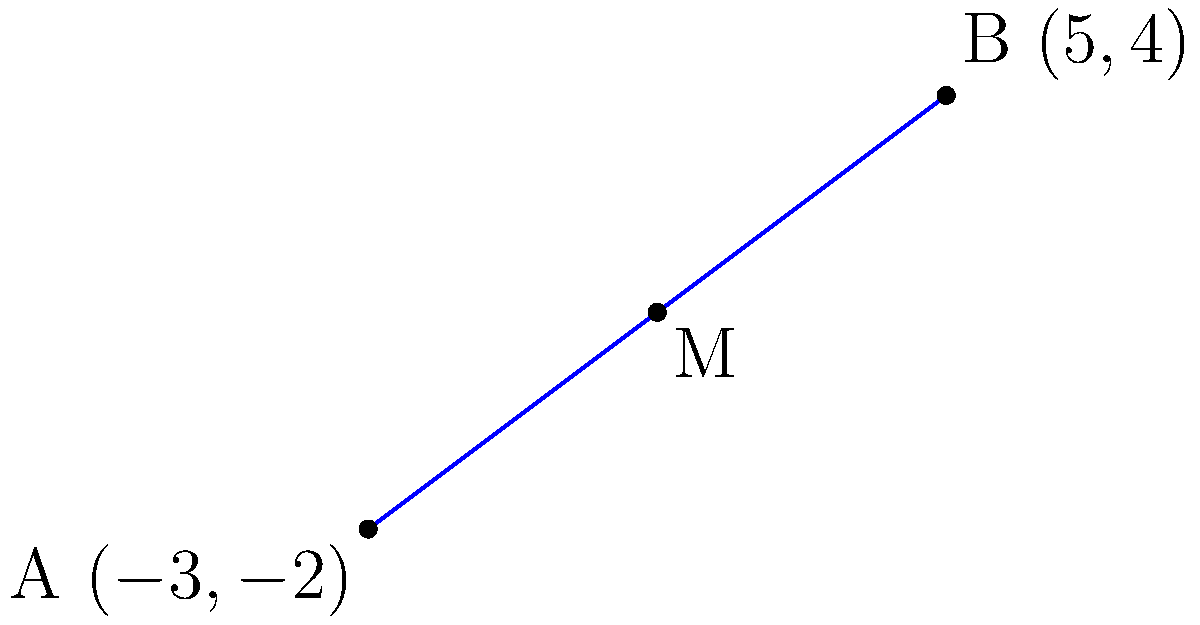A technology company operates two data centers located at coordinates $A(-3,-2)$ and $B(5,4)$ on a network map. To optimize network performance, they need to install a load balancer at the midpoint of the connection between these data centers. Calculate the coordinates of the midpoint $M$ where the load balancer should be installed. To find the midpoint of a line segment, we use the midpoint formula:

$M_x = \frac{x_1 + x_2}{2}$ and $M_y = \frac{y_1 + y_2}{2}$

Where $(x_1, y_1)$ are the coordinates of point $A$, and $(x_2, y_2)$ are the coordinates of point $B$.

Step 1: Identify the coordinates
$A(-3,-2)$ and $B(5,4)$

Step 2: Calculate $M_x$
$M_x = \frac{-3 + 5}{2} = \frac{2}{2} = 1$

Step 3: Calculate $M_y$
$M_y = \frac{-2 + 4}{2} = \frac{2}{2} = 1$

Step 4: Combine the results
The midpoint $M$ has coordinates $(1,1)$
Answer: $(1,1)$ 